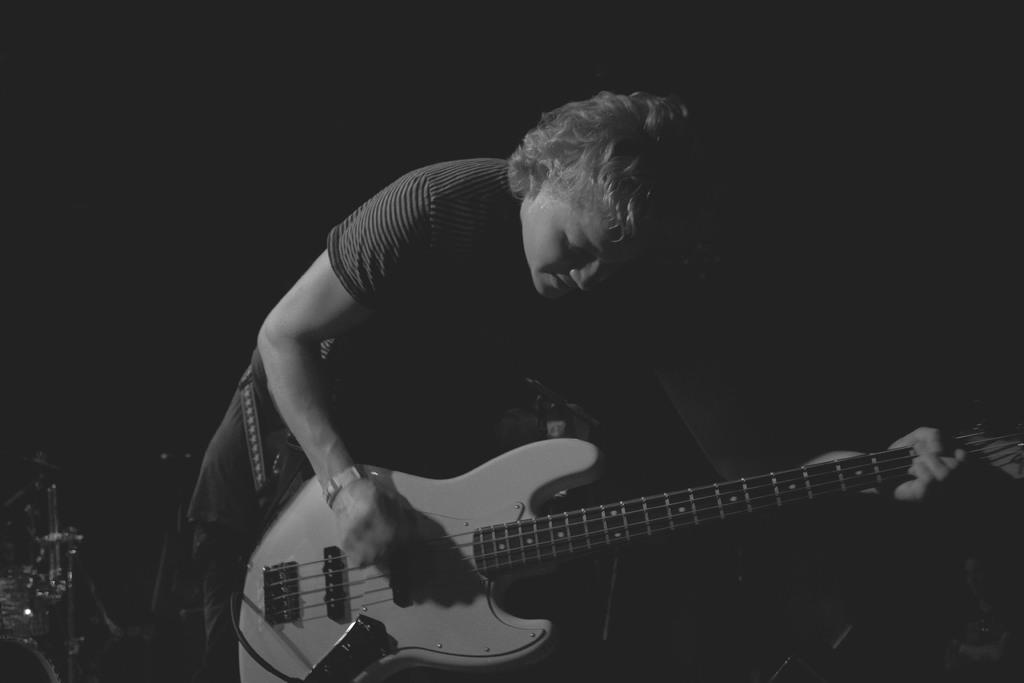Please provide a concise description of this image. As we can see in the image there is a woman dressed in yellow color. She is holding a guitar. 